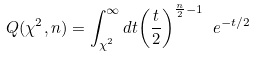<formula> <loc_0><loc_0><loc_500><loc_500>Q ( \chi ^ { 2 } , n ) = \int _ { \chi ^ { 2 } } ^ { \infty } d t { \left ( \frac { t } { 2 } \right ) } ^ { \frac { n } { 2 } - 1 } \ e ^ { - t / 2 }</formula> 